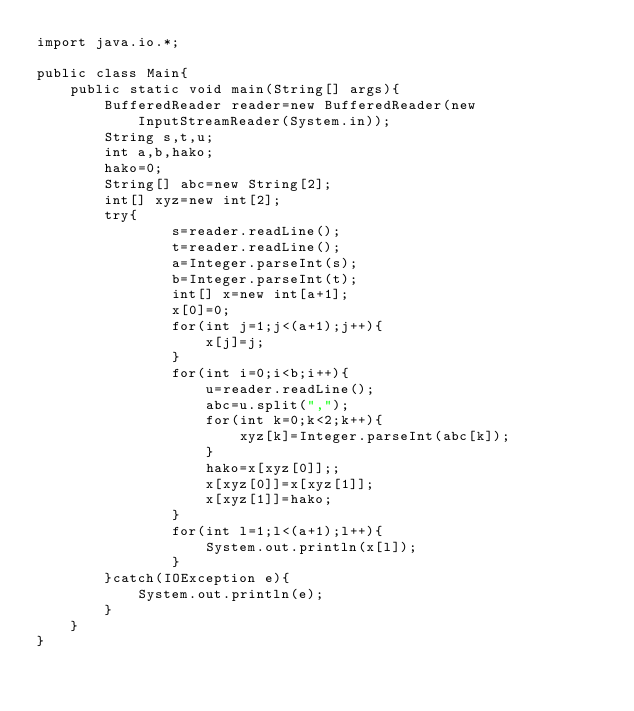<code> <loc_0><loc_0><loc_500><loc_500><_Java_>import java.io.*;

public class Main{
	public static void main(String[] args){
		BufferedReader reader=new BufferedReader(new InputStreamReader(System.in));
		String s,t,u;
		int a,b,hako;
		hako=0;
		String[] abc=new String[2];
		int[] xyz=new int[2];
		try{
				s=reader.readLine();
				t=reader.readLine();
				a=Integer.parseInt(s);
				b=Integer.parseInt(t);
				int[] x=new int[a+1];
				x[0]=0;
				for(int j=1;j<(a+1);j++){
					x[j]=j;
				}
				for(int i=0;i<b;i++){
					u=reader.readLine();
					abc=u.split(",");
					for(int k=0;k<2;k++){
						xyz[k]=Integer.parseInt(abc[k]);
					}
					hako=x[xyz[0]];;
					x[xyz[0]]=x[xyz[1]];
					x[xyz[1]]=hako;
				}
				for(int l=1;l<(a+1);l++){
					System.out.println(x[l]);
				}
		}catch(IOException e){
			System.out.println(e);
		}
	}
}</code> 